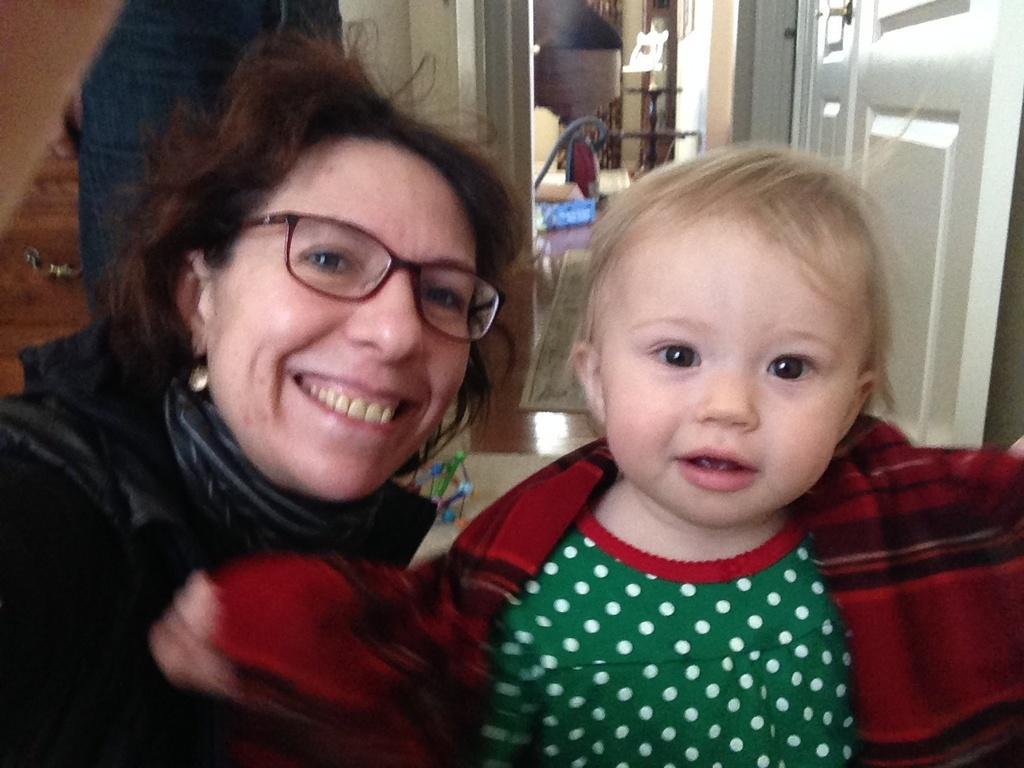Please provide a concise description of this image. In the foreground of this image, there is a woman and a kid. Woman in black dress and kid in green and red dress. In the background, there is a door, a person, wall and few objects. 